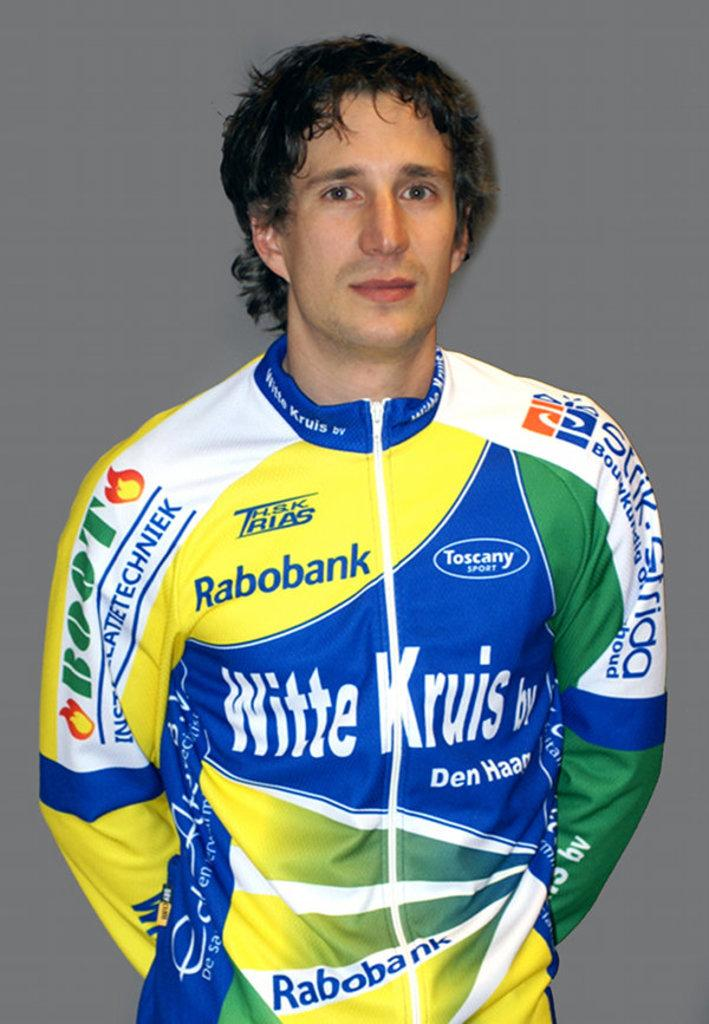Provide a one-sentence caption for the provided image. An auto racer's uniform is covered in ads for Rabobank and Toscany Sport, among others. 